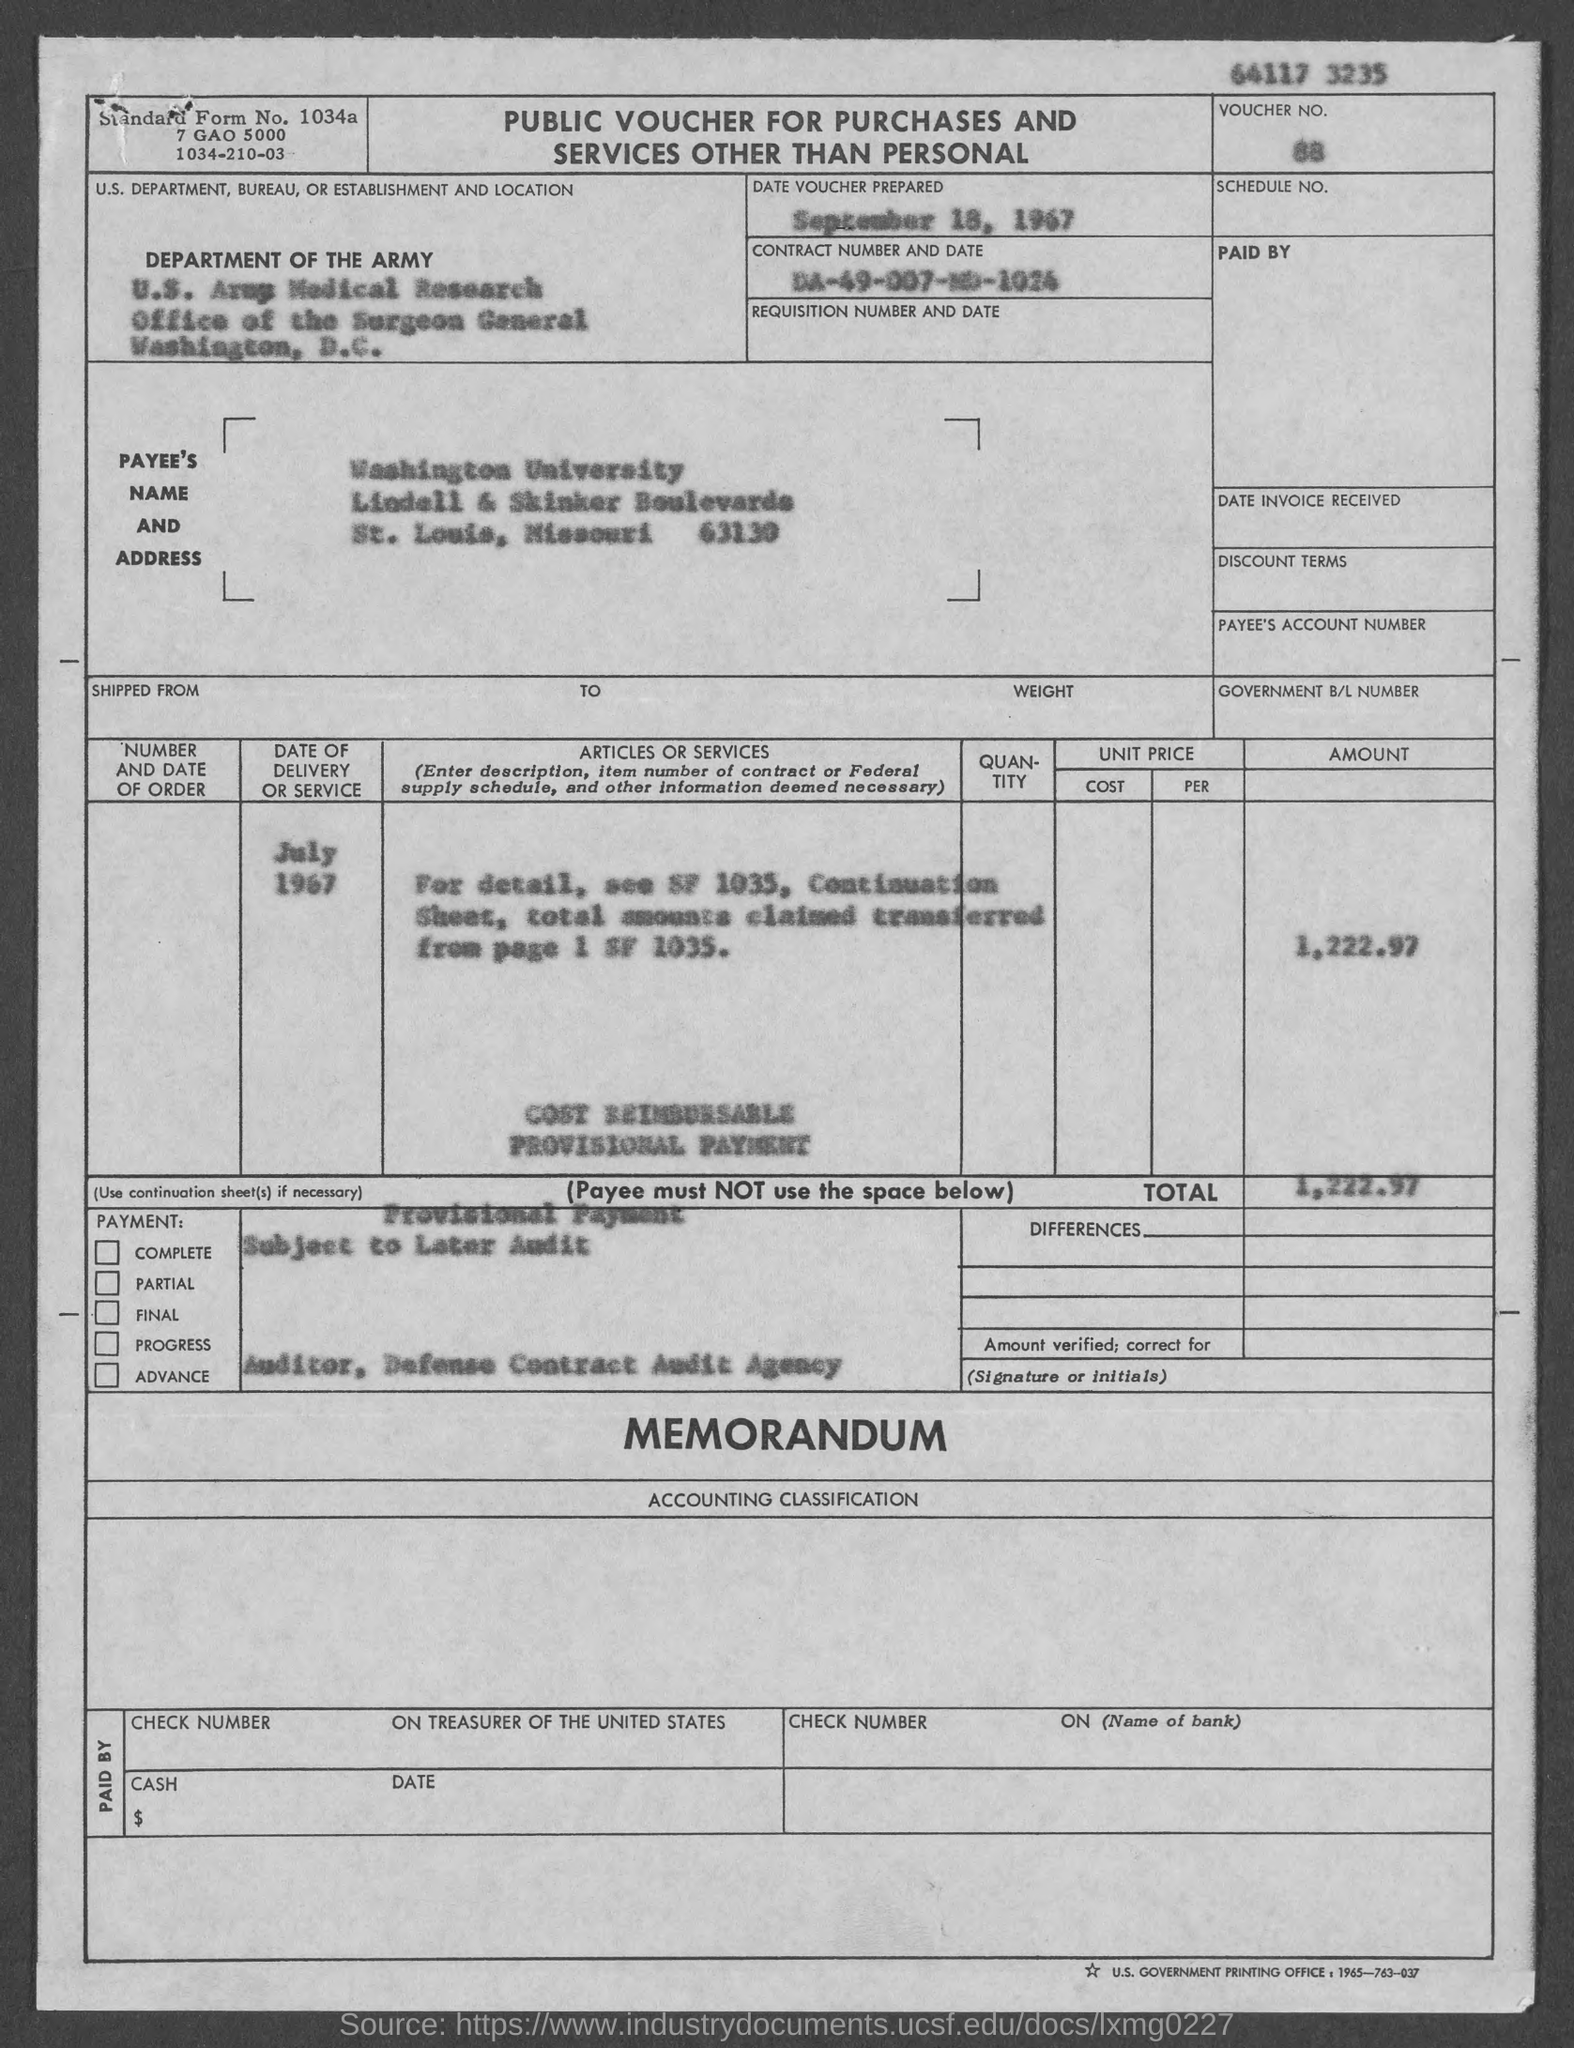Outline some significant characteristics in this image. The Office of the Surgeon General is located in Washington, the city where it resides. The voucher was prepared on September 18, 1967. The voucher number is 88. Washington University is located in the state of Missouri. The total is 1,222.97. 